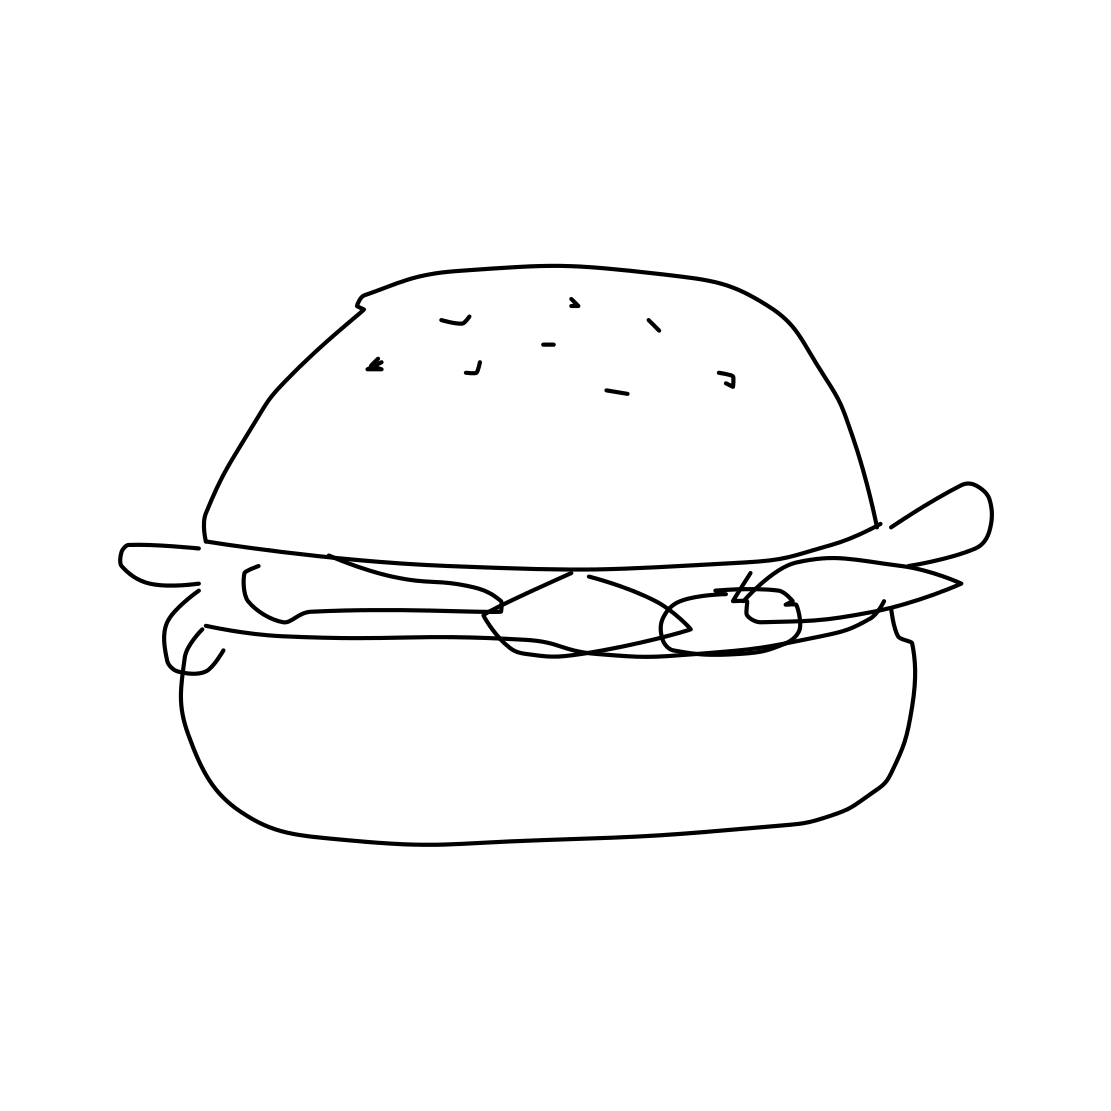What ingredients can be identified in the hamburger depicted? The hamburger includes top and bottom buns, seeds on the top bun, a meat patty, and some leafy greens which might indicate lettuce. The outline suggests a typical burger composition. Does anything about this hamburger stand out as unusual or unique? The simplicity of the design stands out; it's represented in a minimalistic, almost cartoonish style, which captures the basic elements of a hamburger but without detailed texture or color. 